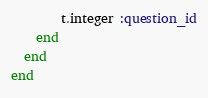Convert code to text. <code><loc_0><loc_0><loc_500><loc_500><_Ruby_>  		t.integer :question_id
  	end
  end
end
</code> 